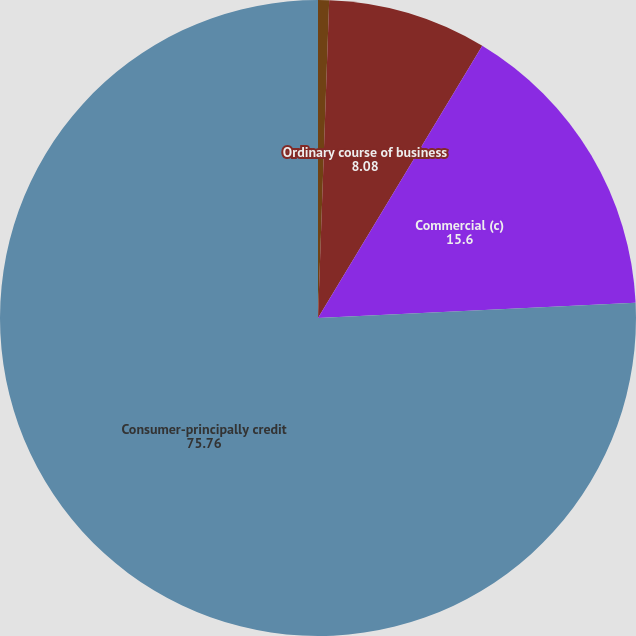<chart> <loc_0><loc_0><loc_500><loc_500><pie_chart><fcel>December 31 (In millions)<fcel>Ordinary course of business<fcel>Commercial (c)<fcel>Consumer-principally credit<nl><fcel>0.56%<fcel>8.08%<fcel>15.6%<fcel>75.76%<nl></chart> 